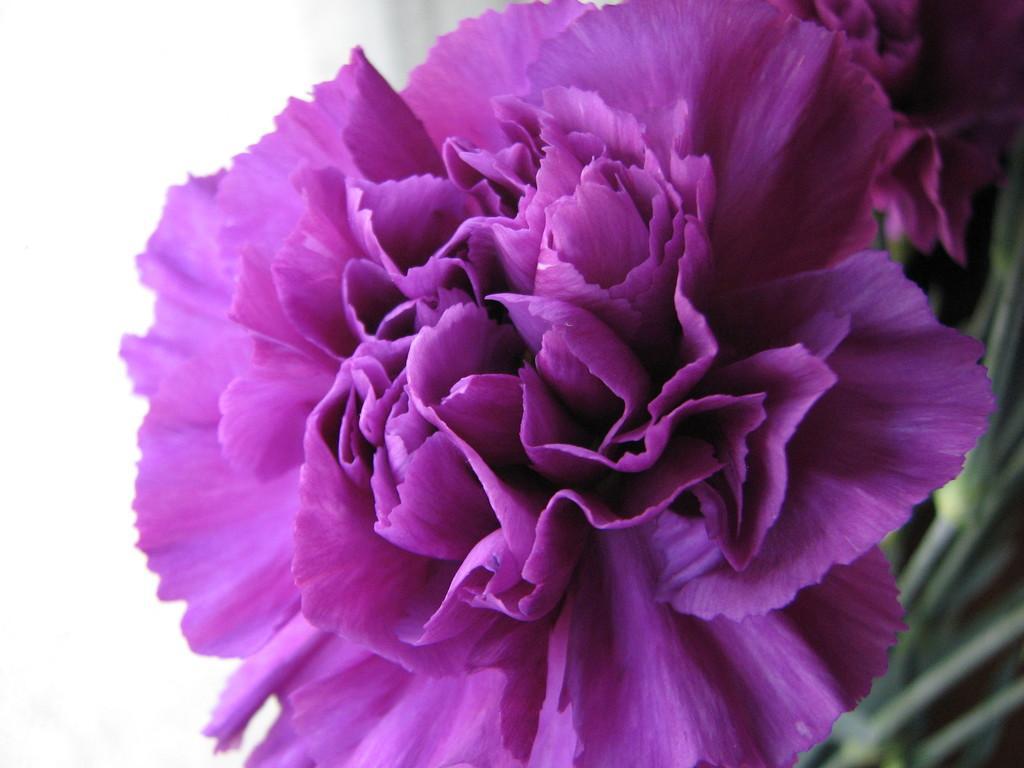How would you summarize this image in a sentence or two? In the picture we can see flower which is in purple color. 